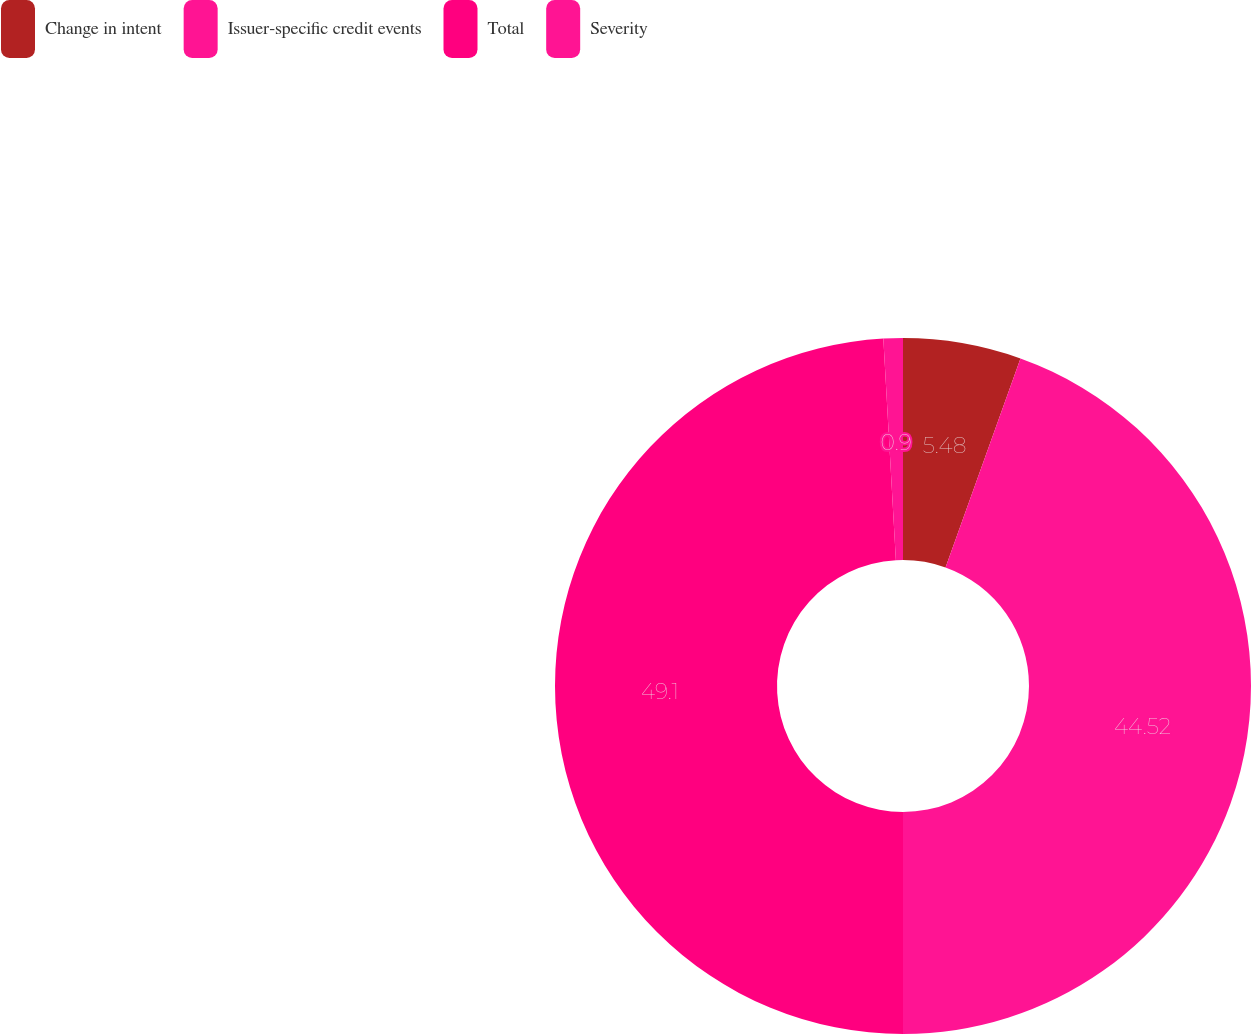Convert chart. <chart><loc_0><loc_0><loc_500><loc_500><pie_chart><fcel>Change in intent<fcel>Issuer-specific credit events<fcel>Total<fcel>Severity<nl><fcel>5.48%<fcel>44.52%<fcel>49.1%<fcel>0.9%<nl></chart> 